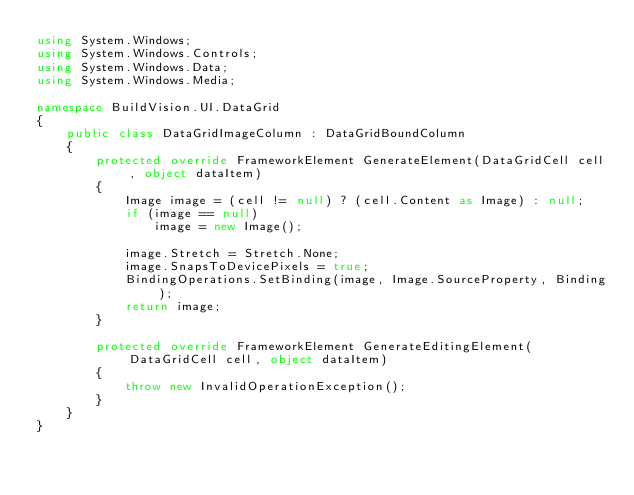Convert code to text. <code><loc_0><loc_0><loc_500><loc_500><_C#_>using System.Windows;
using System.Windows.Controls;
using System.Windows.Data;
using System.Windows.Media;

namespace BuildVision.UI.DataGrid
{
    public class DataGridImageColumn : DataGridBoundColumn
    {
        protected override FrameworkElement GenerateElement(DataGridCell cell, object dataItem)
        {
            Image image = (cell != null) ? (cell.Content as Image) : null;
            if (image == null)
                image = new Image();

            image.Stretch = Stretch.None;
            image.SnapsToDevicePixels = true;
            BindingOperations.SetBinding(image, Image.SourceProperty, Binding);
            return image;
        }

        protected override FrameworkElement GenerateEditingElement(DataGridCell cell, object dataItem)
        {
            throw new InvalidOperationException();
        }
    }
}</code> 